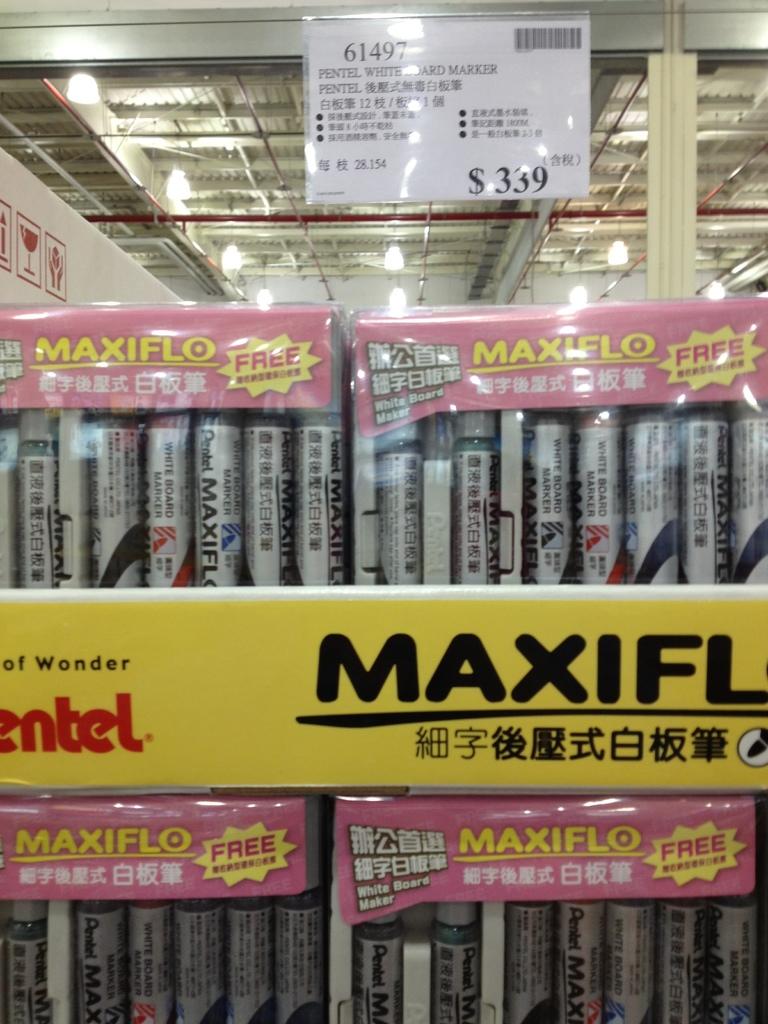What word starts with m?
Provide a short and direct response. Maxifl. 